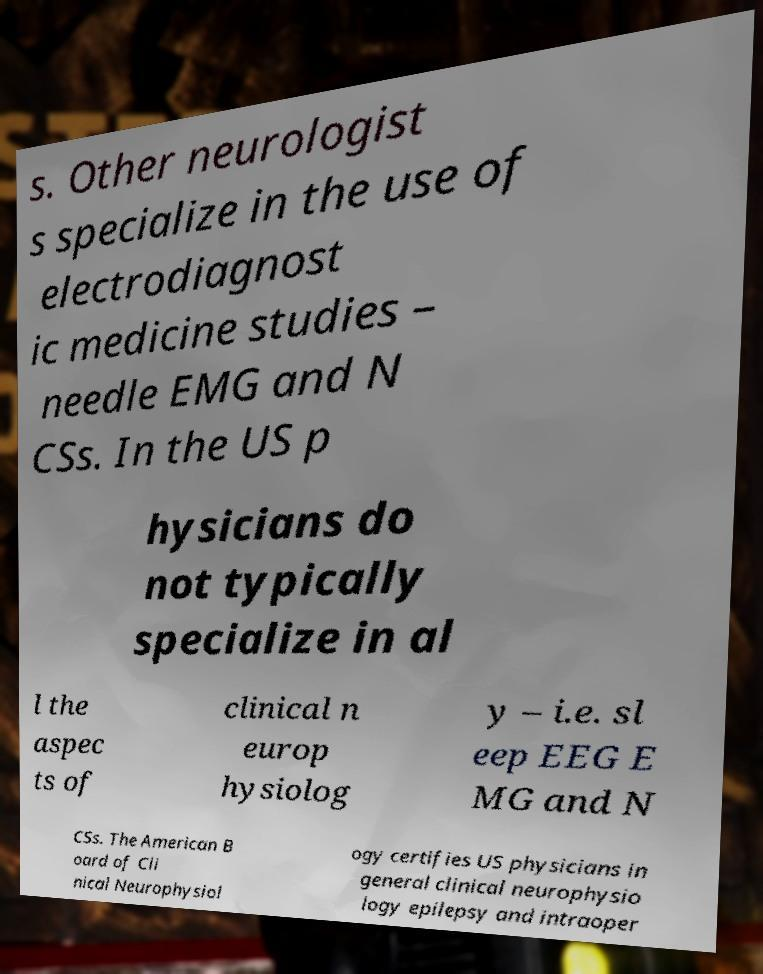I need the written content from this picture converted into text. Can you do that? s. Other neurologist s specialize in the use of electrodiagnost ic medicine studies – needle EMG and N CSs. In the US p hysicians do not typically specialize in al l the aspec ts of clinical n europ hysiolog y – i.e. sl eep EEG E MG and N CSs. The American B oard of Cli nical Neurophysiol ogy certifies US physicians in general clinical neurophysio logy epilepsy and intraoper 